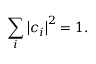<formula> <loc_0><loc_0><loc_500><loc_500>\sum _ { i } \left | c _ { i } \right | ^ { 2 } = 1 .</formula> 